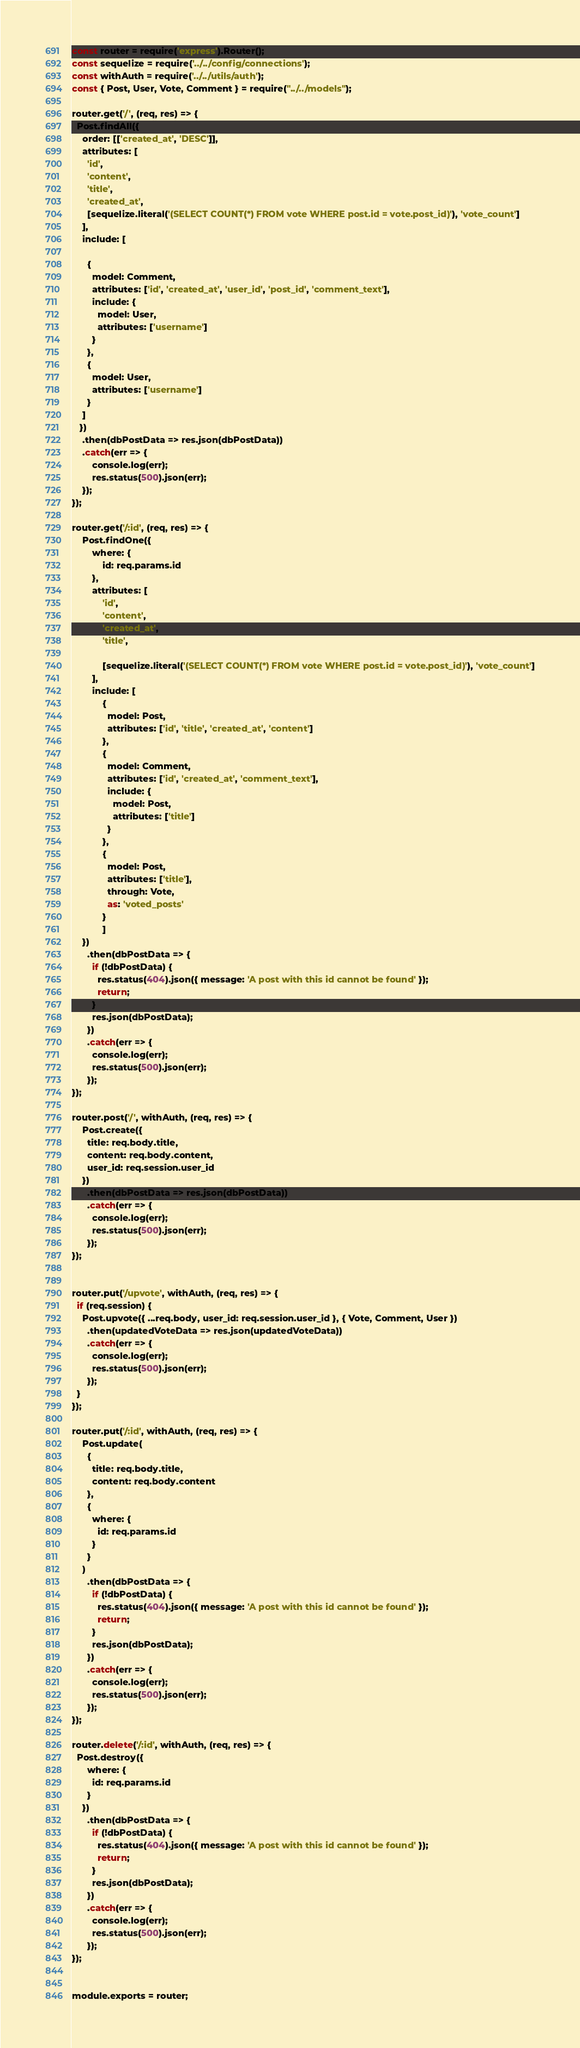<code> <loc_0><loc_0><loc_500><loc_500><_JavaScript_>const router = require('express').Router();
const sequelize = require('../../config/connections');
const withAuth = require('../../utils/auth');
const { Post, User, Vote, Comment } = require("../../models");

router.get('/', (req, res) => {
  Post.findAll({
    order: [['created_at', 'DESC']],
    attributes: [
      'id',
      'content',
      'title',
      'created_at',
      [sequelize.literal('(SELECT COUNT(*) FROM vote WHERE post.id = vote.post_id)'), 'vote_count']
    ],
    include: [
      
      {
        model: Comment,
        attributes: ['id', 'created_at', 'user_id', 'post_id', 'comment_text'],
        include: {
          model: User,
          attributes: ['username']
        }
      },
      {
        model: User,
        attributes: ['username']
      }
    ]
   })   
    .then(dbPostData => res.json(dbPostData))
    .catch(err => {
        console.log(err);
        res.status(500).json(err);
    });
});  

router.get('/:id', (req, res) => {
    Post.findOne({
        where: {
            id: req.params.id
        },
        attributes: [
            'id',
            'content',
            'created_at',
            'title',

            [sequelize.literal('(SELECT COUNT(*) FROM vote WHERE post.id = vote.post_id)'), 'vote_count']
        ],
        include: [
            {
              model: Post,
              attributes: ['id', 'title', 'created_at', 'content']
            },
            {
              model: Comment,
              attributes: ['id', 'created_at', 'comment_text'],
              include: {
                model: Post,
                attributes: ['title']
              }
            },
            {
              model: Post,
              attributes: ['title'],
              through: Vote,
              as: 'voted_posts'
            }
            ]
    })
      .then(dbPostData => {
        if (!dbPostData) {
          res.status(404).json({ message: 'A post with this id cannot be found' });
          return;
        }
        res.json(dbPostData);
      })
      .catch(err => {
        console.log(err);
        res.status(500).json(err);
      });
});
  
router.post('/', withAuth, (req, res) => {
    Post.create({
      title: req.body.title,
      content: req.body.content,
      user_id: req.session.user_id
    })    
      .then(dbPostData => res.json(dbPostData))
      .catch(err => {
        console.log(err);
        res.status(500).json(err);
      });
});


router.put('/upvote', withAuth, (req, res) => {
  if (req.session) {
    Post.upvote({ ...req.body, user_id: req.session.user_id }, { Vote, Comment, User })
      .then(updatedVoteData => res.json(updatedVoteData))
      .catch(err => {
        console.log(err);
        res.status(500).json(err);
      });
  }
});

router.put('/:id', withAuth, (req, res) => {
    Post.update(
      {
        title: req.body.title,
        content: req.body.content
      },
      {
        where: {
          id: req.params.id
        }
      }
    )
      .then(dbPostData => {
        if (!dbPostData) {
          res.status(404).json({ message: 'A post with this id cannot be found' });
          return;
        }
        res.json(dbPostData);
      })
      .catch(err => {
        console.log(err);
        res.status(500).json(err);
      });
});  
 
router.delete('/:id', withAuth, (req, res) => {
  Post.destroy({
      where: {
        id: req.params.id
      }
    })
      .then(dbPostData => {
        if (!dbPostData) {
          res.status(404).json({ message: 'A post with this id cannot be found' });
          return;
        }
        res.json(dbPostData);
      })
      .catch(err => {
        console.log(err);
        res.status(500).json(err);
      });
});
  

module.exports = router;</code> 